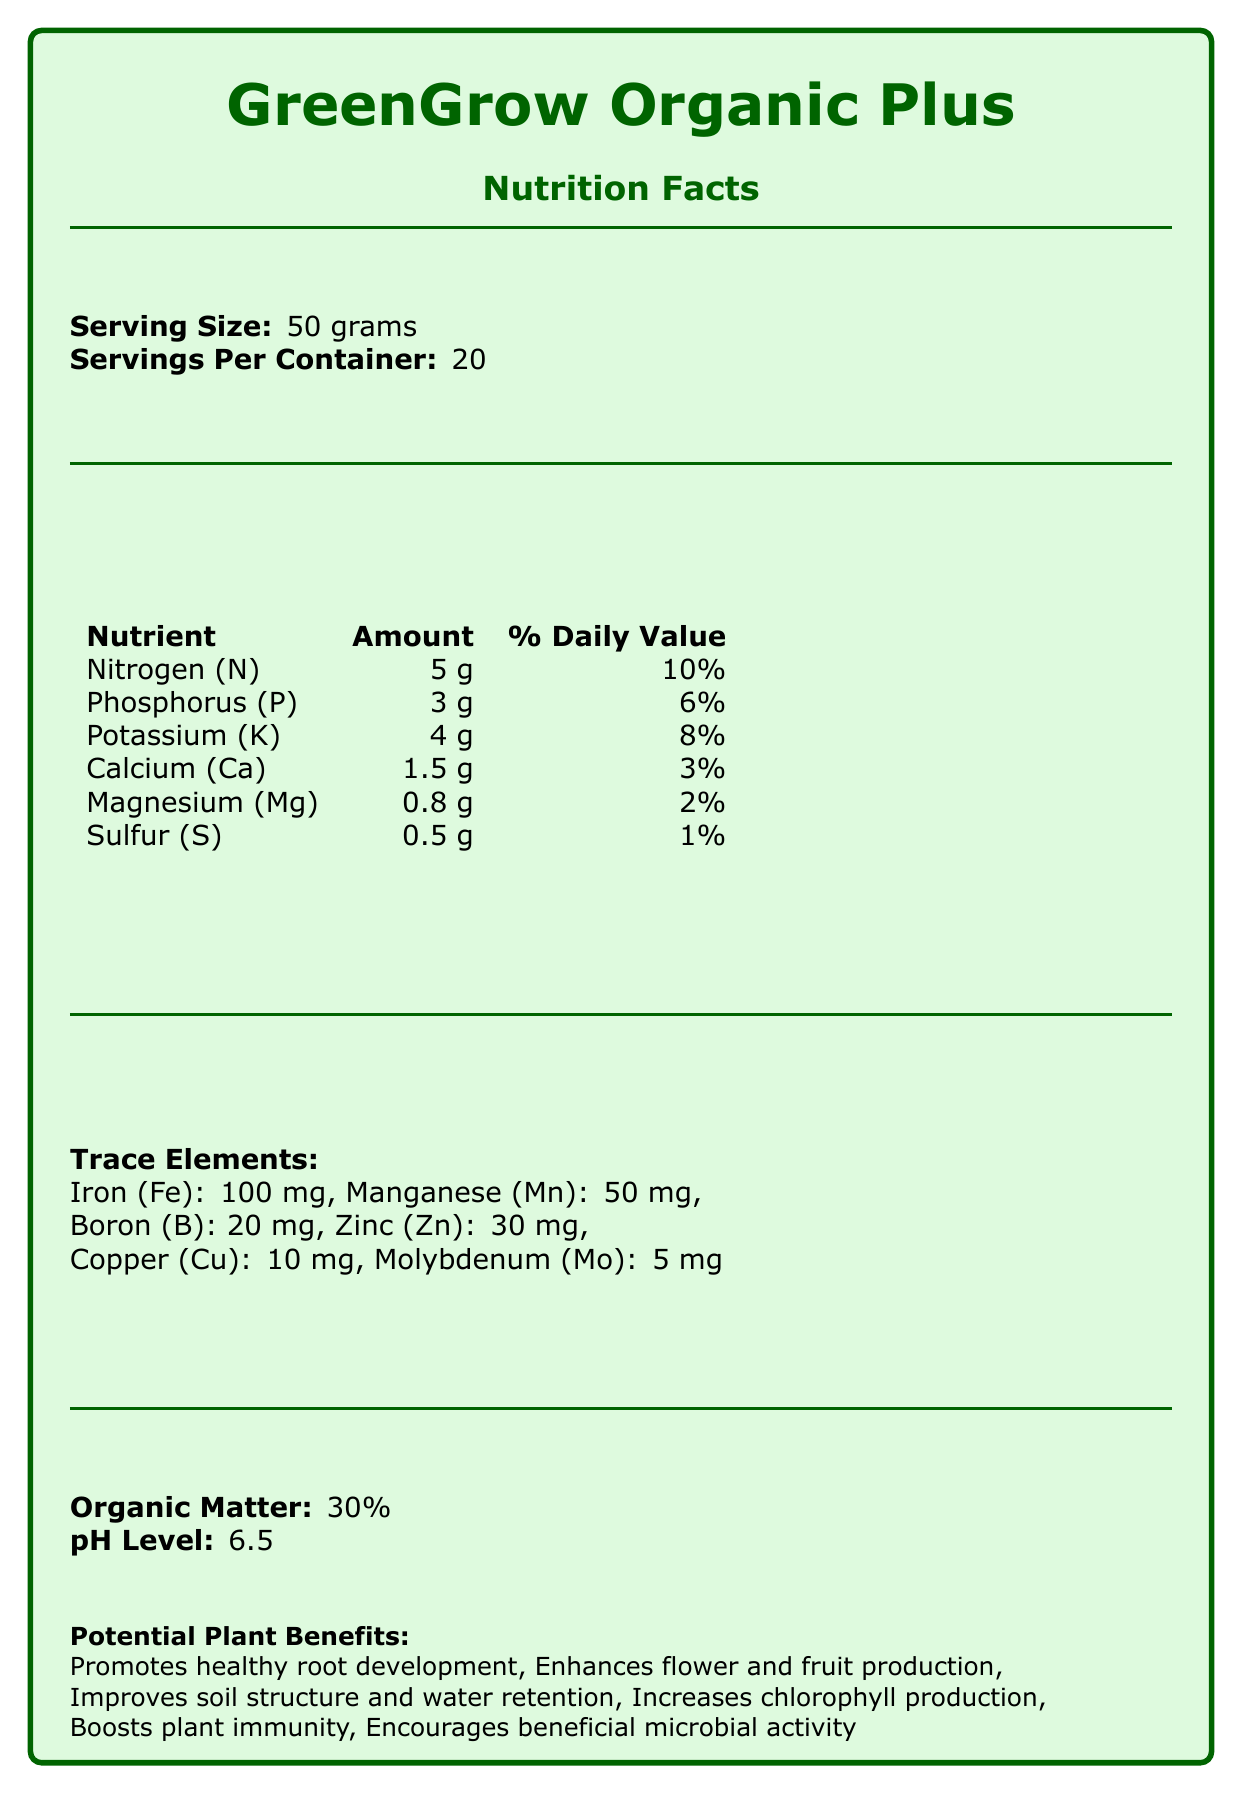what is the serving size of GreenGrow Organic Plus? The serving size is clearly stated as "Serving Size: 50 grams" at the top.
Answer: 50 grams how many servings are there per container of GreenGrow Organic Plus? The document mentions "Servings Per Container: 20" right below the serving size.
Answer: 20 what are the main nutrients found in GreenGrow Organic Plus? The nutrients are listed with their corresponding amounts and percent daily values.
Answer: Nitrogen (N), Phosphorus (P), Potassium (K), Calcium (Ca), Magnesium (Mg), Sulfur (S) how much Iron (Fe) does GreenGrow Organic Plus contain? Iron (Fe) is listed among the trace elements with an amount of 100 mg.
Answer: 100 mg what is the organic matter percentage of GreenGrow Organic Plus? Under the section "Organic Matter:", it states 30%.
Answer: 30% which nutrient has the highest percent daily value in GreenGrow Organic Plus? A. Potassium B. Calcium C. Nitrogen D. Sulfur Nitrogen (N) has the highest daily value at 10%.
Answer: C how often should GreenGrow Organic Plus be applied? A. Every 2-3 weeks B. Every 4-6 weeks C. Monthly D. Annually The application frequency is listed as "Apply every 4-6 weeks during growing season."
Answer: B is GreenGrow Organic Plus suitable for container gardens? Container gardens are included in the "suitable for" section.
Answer: Yes is the pH level of GreenGrow Organic Plus acidic, neutral, or basic? A pH level of 6.5 is slightly acidic.
Answer: Slightly acidic what certifications does GreenGrow Organic Plus have? The document lists all three certifications under the "certifications" section.
Answer: USDA Organic, OMRI Listed, Non-GMO Project Verified summarize the main idea of the document. The document provides detailed information on the nutrient content, benefits, and usage guidelines of GreenGrow Organic Plus, emphasizing its organic and sustainable nature.
Answer: GreenGrow Organic Plus is an organic fertilizer containing essential nutrients and trace elements, promoting various plant benefits such as healthy root development and enhanced flower and fruit production. It is suitable for a wide range of plants and has several organic certifications. does GreenGrow Organic Plus contain any artificial chemicals? The document does not specify whether artificial chemicals are completely absent, only mentioning organic and natural ingredients.
Answer: Cannot be determined what application rate is recommended for GreenGrow Organic Plus? The document states the application rate as "100 g per square meter".
Answer: 100 g per square meter 